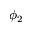Convert formula to latex. <formula><loc_0><loc_0><loc_500><loc_500>\phi _ { 2 }</formula> 